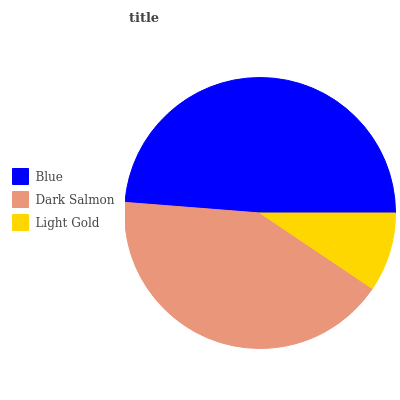Is Light Gold the minimum?
Answer yes or no. Yes. Is Blue the maximum?
Answer yes or no. Yes. Is Dark Salmon the minimum?
Answer yes or no. No. Is Dark Salmon the maximum?
Answer yes or no. No. Is Blue greater than Dark Salmon?
Answer yes or no. Yes. Is Dark Salmon less than Blue?
Answer yes or no. Yes. Is Dark Salmon greater than Blue?
Answer yes or no. No. Is Blue less than Dark Salmon?
Answer yes or no. No. Is Dark Salmon the high median?
Answer yes or no. Yes. Is Dark Salmon the low median?
Answer yes or no. Yes. Is Light Gold the high median?
Answer yes or no. No. Is Light Gold the low median?
Answer yes or no. No. 